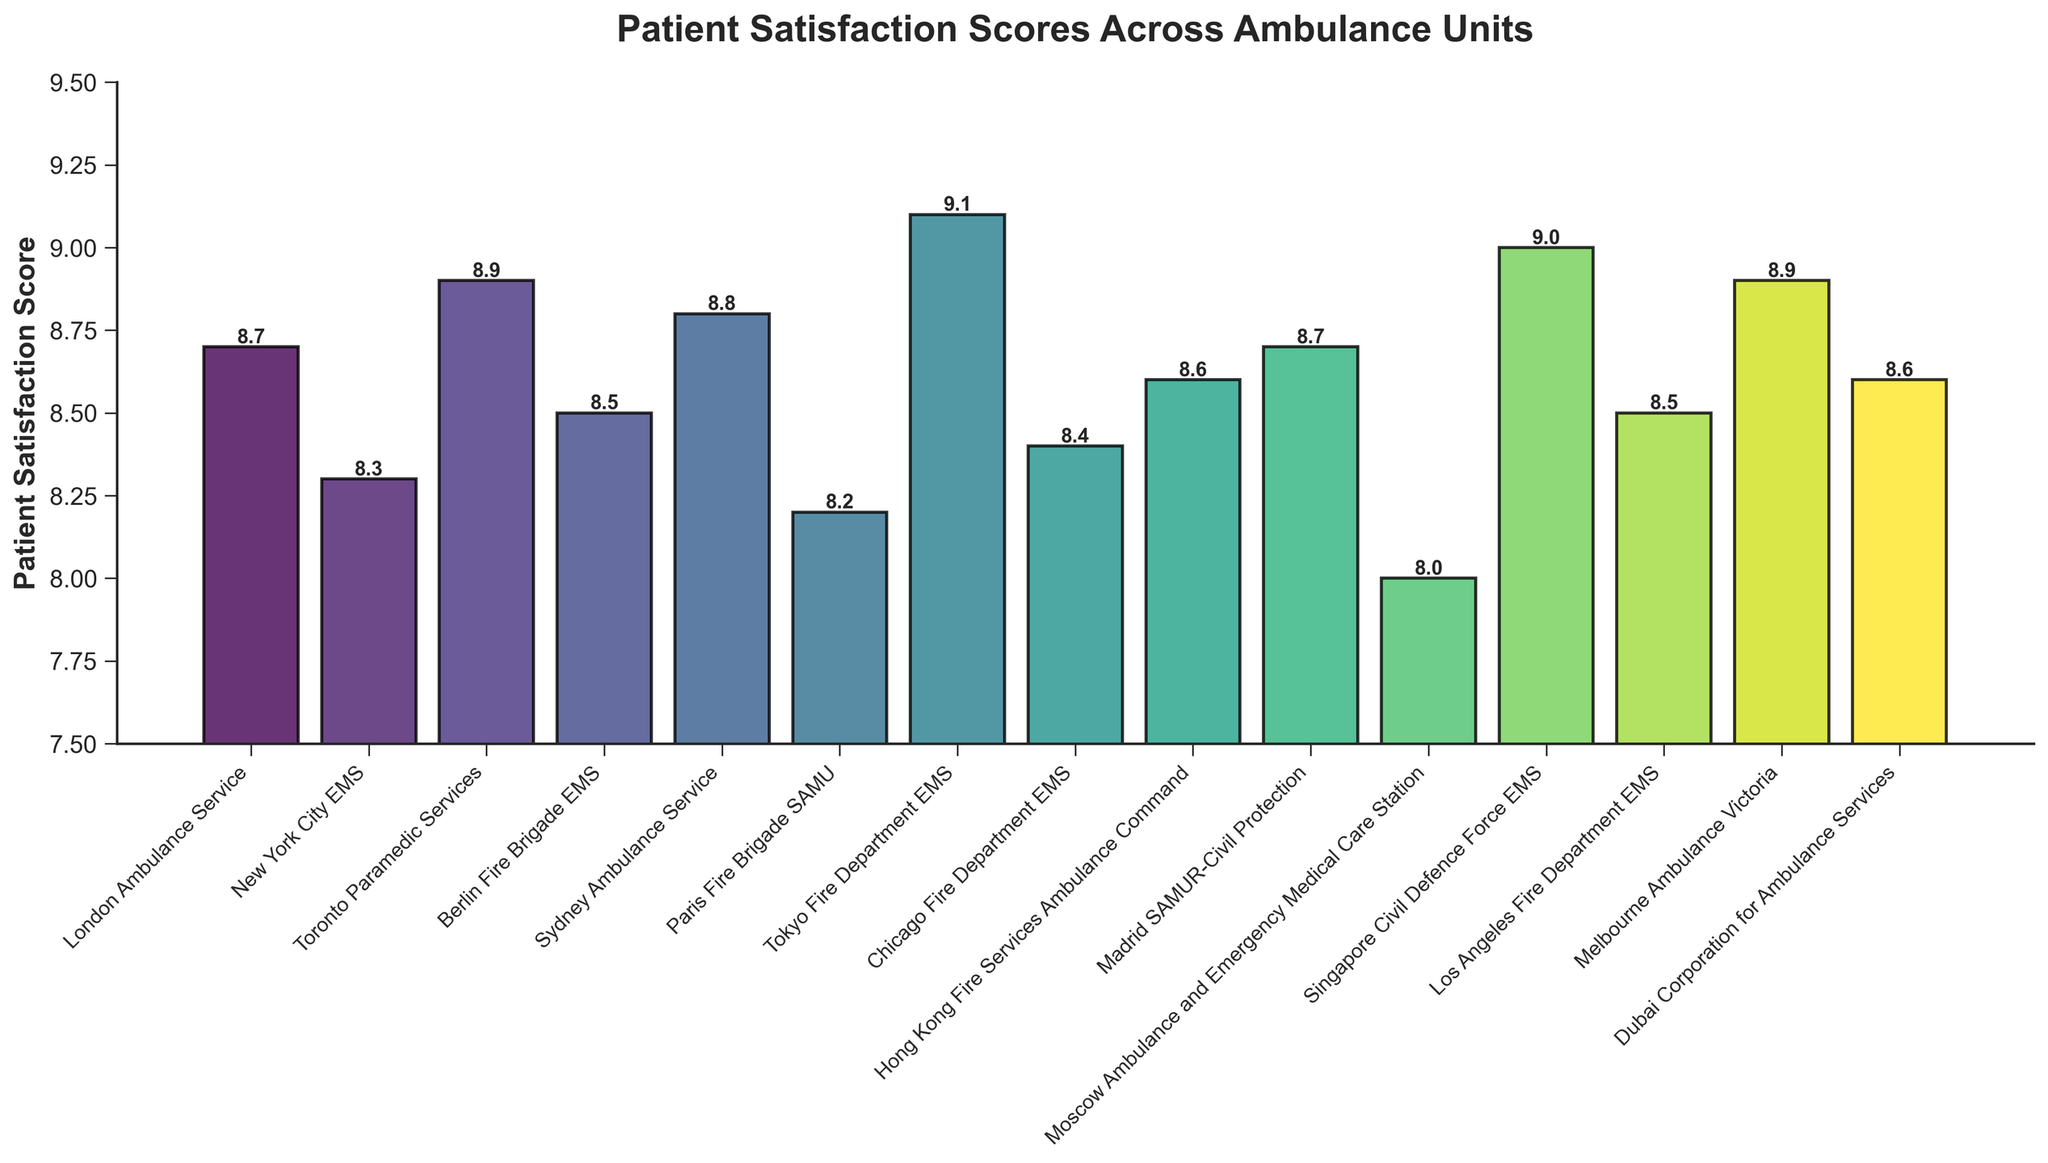Which ambulance unit has the highest patient satisfaction score? The figure shows that the Tokyo Fire Department EMS has the highest bar, indicating it has the highest patient satisfaction score.
Answer: Tokyo Fire Department EMS Which ambulance unit has the lowest patient satisfaction score? The figure displays that the Moscow Ambulance and Emergency Medical Care Station has the shortest bar, indicating the lowest patient satisfaction score.
Answer: Moscow Ambulance and Emergency Medical Care Station What is the difference in patient satisfaction scores between the Sydney Ambulance Service and the Los Angeles Fire Department EMS? The Sydney Ambulance Service has a score of 8.8 and the Los Angeles Fire Department EMS has a score of 8.5. The difference is calculated as 8.8 - 8.5.
Answer: 0.3 Which ambulance units have a patient satisfaction score greater than 9.0? The figure shows the bars for the Tokyo Fire Department EMS and the Singapore Civil Defence Force EMS are above the 9.0 line.
Answer: Tokyo Fire Department EMS, Singapore Civil Defence Force EMS What is the median patient satisfaction score across all ambulance units? First, order the scores: 8.0, 8.2, 8.3, 8.4, 8.5, 8.5, 8.6, 8.6, 8.7, 8.7, 8.8, 8.9, 8.9, 9.0, 9.1. The median is the middle value. Here, it's the 8th value in the ordered list.
Answer: 8.6 Which ambulance unit has a patient satisfaction score closest to 8.5? The figure shows multiple units around 8.5, but the Chicago Fire Department EMS and Los Angeles Fire Department EMS precisely have this score.
Answer: Chicago Fire Department EMS, Los Angeles Fire Department EMS What is the average patient satisfaction score across all ambulance units? Sum all the scores: 8.7+8.3+8.9+8.5+8.8+8.2+9.1+8.4+8.6+8.7+8.0+9.0+8.5+8.9+8.6 = 129.2. There are 15 units, so the average score is 129.2 / 15.
Answer: 8.61 What is the total number of ambulance units with scores below 8.5? The figure shows that Paris Fire Brigade SAMU (8.2), New York City EMS (8.3), and Moscow Ambulance and Emergency Medical Care Station (8.0) have scores below 8.5. There are 3 such units.
Answer: 3 How many ambulance units have patient satisfaction scores above 8.5? The figure shows that London, Sydney, Tokyo, Singapore, Toronto, Melbourne, Hong Kong, and Dubai have scores above 8.5. There are 8 such units.
Answer: 8 What is the combined patient satisfaction score of the Tokyo Fire Department EMS and the Singapore Civil Defence Force EMS? Tokyo has a score of 9.1, and Singapore has a score of 9.0. Sum them up gives 9.1 + 9.0.
Answer: 18.1 